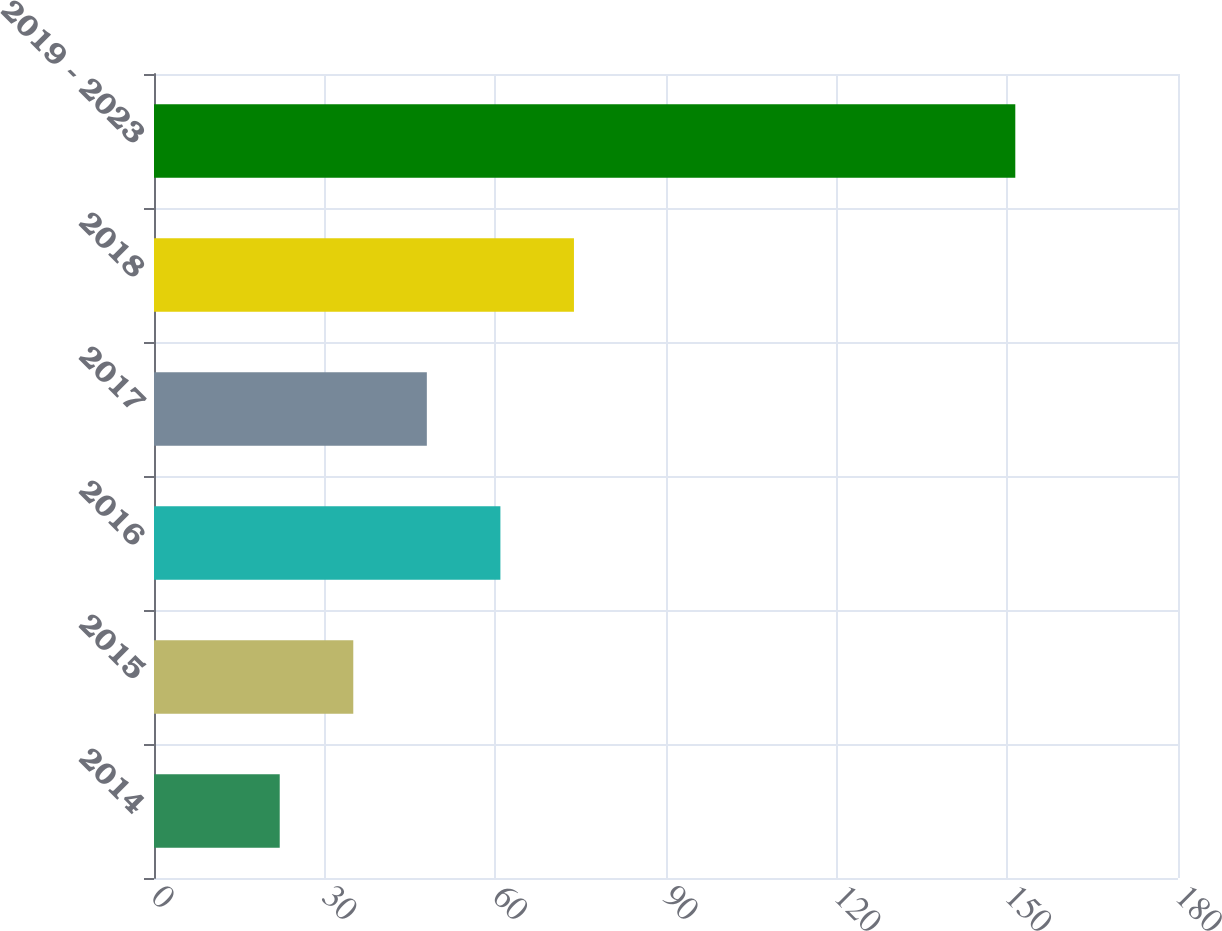Convert chart to OTSL. <chart><loc_0><loc_0><loc_500><loc_500><bar_chart><fcel>2014<fcel>2015<fcel>2016<fcel>2017<fcel>2018<fcel>2019 - 2023<nl><fcel>22.1<fcel>35.03<fcel>60.89<fcel>47.96<fcel>73.82<fcel>151.4<nl></chart> 